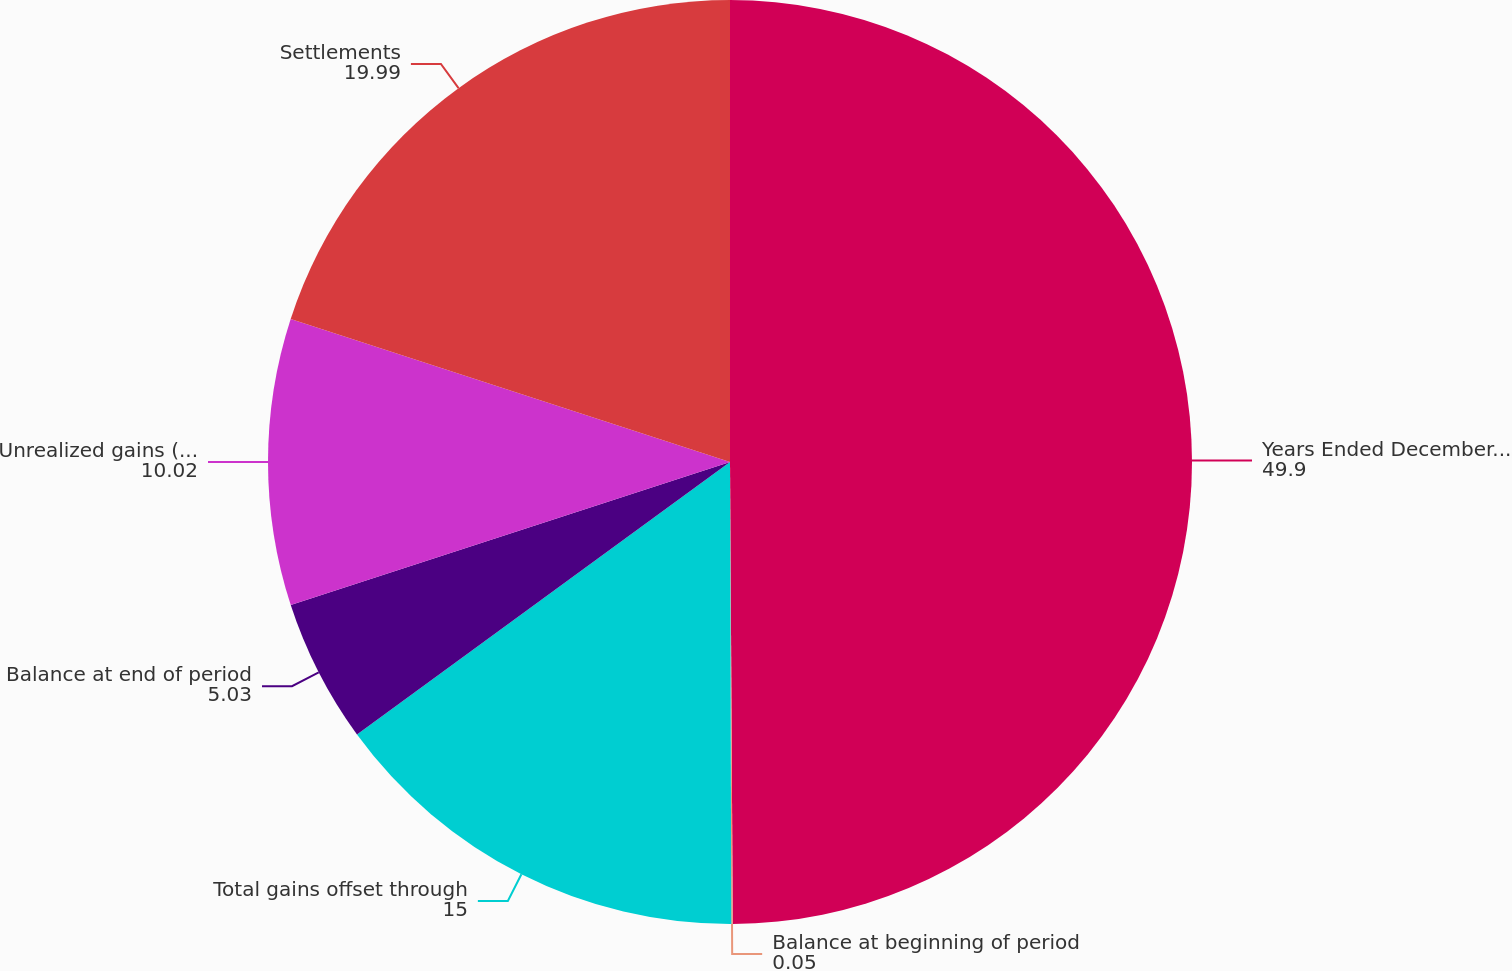Convert chart. <chart><loc_0><loc_0><loc_500><loc_500><pie_chart><fcel>Years Ended December 31<fcel>Balance at beginning of period<fcel>Total gains offset through<fcel>Balance at end of period<fcel>Unrealized gains (losses)<fcel>Settlements<nl><fcel>49.9%<fcel>0.05%<fcel>15.0%<fcel>5.03%<fcel>10.02%<fcel>19.99%<nl></chart> 